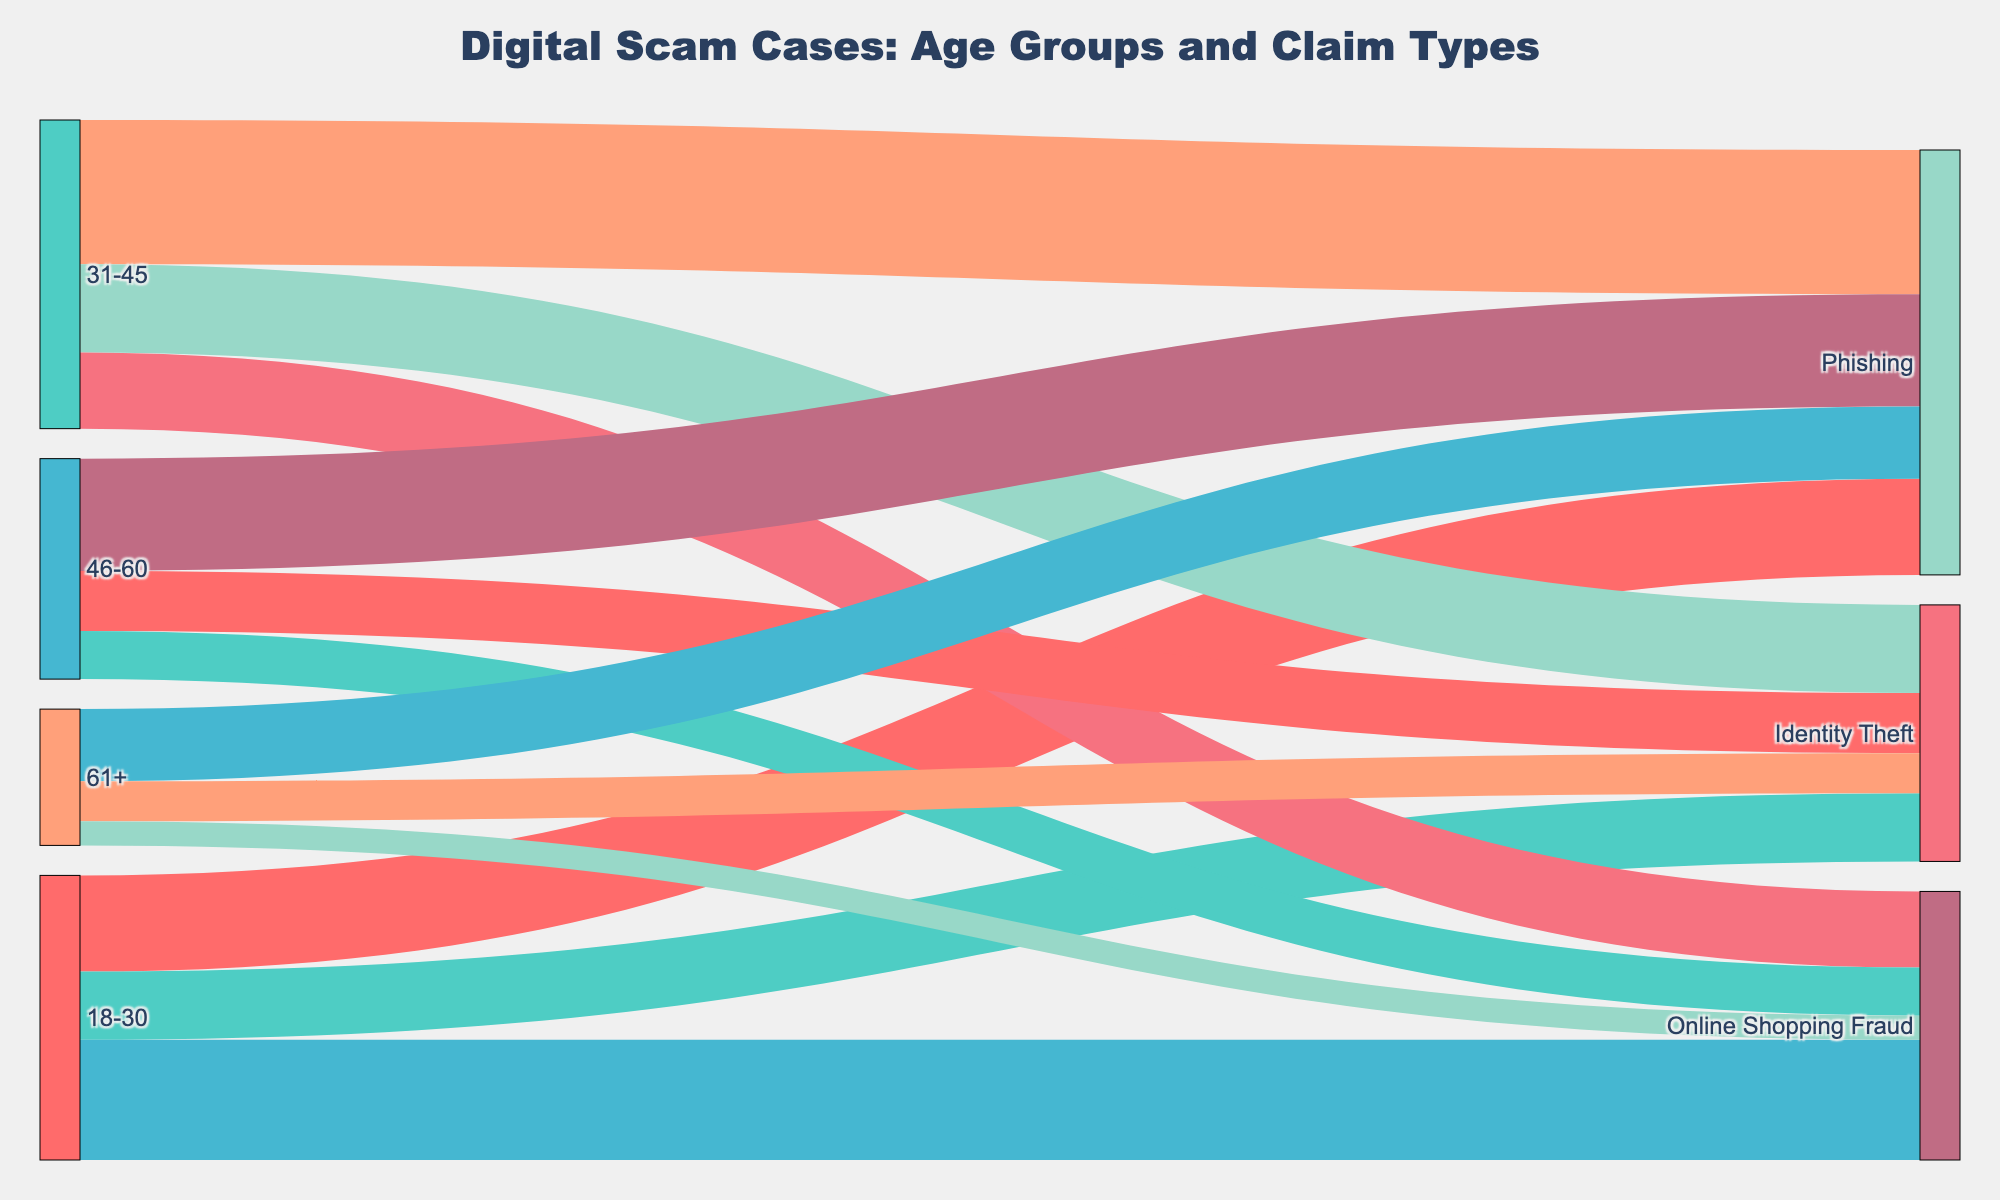How many distinct claim types are represented in the diagram? The Sankey diagram shows three different claim types as visible in the labeled nodes connected to the age groups.
Answer: 3 Which age group has the highest frequency of phishing claims? By examining the width of the links from age groups to claim types, the 31-45 age group has the widest link to phishing, indicating the highest frequency.
Answer: 31-45 What is the total frequency of claims for the 46-60 age group? Summing up the frequencies from the 46-60 age group to each claim type: 140 (Phishing) + 75 (Identity Theft) + 60 (Online Shopping Fraud) = 275.
Answer: 275 Which claim type is most frequent for the 18-30 age group? The widest link from the 18-30 age group goes to Online Shopping Fraud, indicating it is the most frequent claim type for this age group.
Answer: Online Shopping Fraud How does the frequency of identity theft claims compare between the 31-45 and 46-60 age groups? Identity theft claims have a higher frequency in the 31-45 age group (110) compared to the 46-60 age group (75), as indicated by the link widths.
Answer: Higher in 31-45 What is the total number of claims for the 61+ age group across all claim types? Adding up frequencies from the 61+ age group to each claim type: 90 (Phishing) + 50 (Identity Theft) + 30 (Online Shopping Fraud) = 170.
Answer: 170 What percentage of the total phishing claims come from the 31-45 age group? Total phishing claims: 120 (18-30) + 180 (31-45) + 140 (46-60) + 90 (61+) = 530. Percentage from 31-45: (180 / 530) * 100 = 33.96%.
Answer: 33.96% Which age group has the lowest total frequency of claims? Summing the frequencies for each age group, the 61+ age group has the lowest total (90 + 50 + 30 = 170 claims).
Answer: 61+ How does the frequency of online shopping fraud claims in the 31-45 age group compare to the 18-30 age group? Online shopping fraud claims for the 31-45 age group is 95, while for the 18-30 age group it is 150. Thus, the 31-45 age group has a lower frequency.
Answer: Lower in 31-45 What is the difference in the frequency of identity theft claims between the 18-30 and 61+ age groups? Subtract the identity theft frequency in the 61+ group (50) from that in the 18-30 group (85). Difference = 85 - 50 = 35.
Answer: 35 